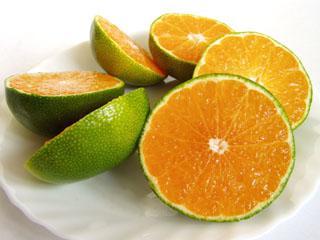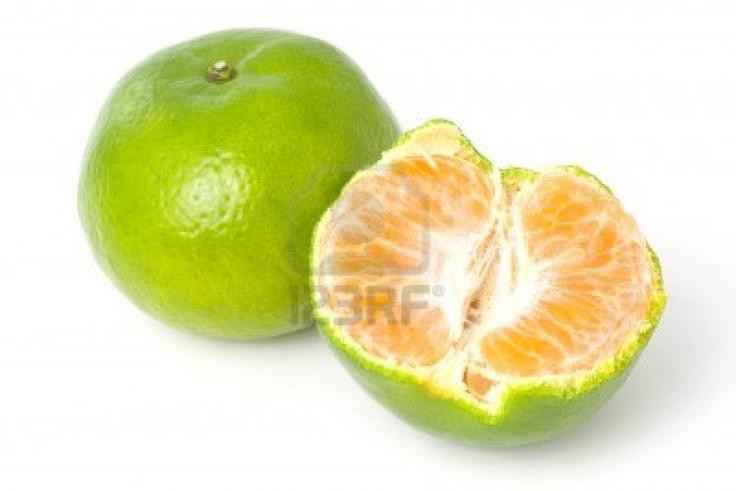The first image is the image on the left, the second image is the image on the right. Given the left and right images, does the statement "There are at least 3 half mandarin fruit slices." hold true? Answer yes or no. Yes. The first image is the image on the left, the second image is the image on the right. Evaluate the accuracy of this statement regarding the images: "The fruit in only ONE of the images was cut with a knife.". Is it true? Answer yes or no. Yes. 